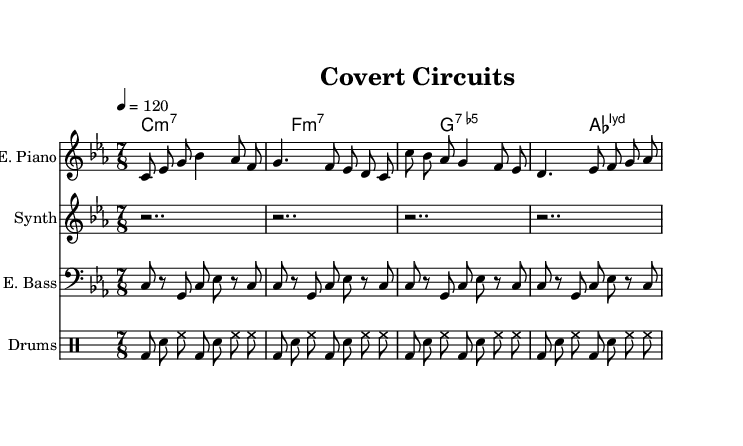What is the key signature of this music? The key signature is C minor, which is indicated by three flats (B♭, E♭, A♭) on the staff.
Answer: C minor What is the time signature of this music? The time signature is shown at the beginning of the music as 7/8, meaning there are seven beats in a bar, and the eighth note gets the beat.
Answer: 7/8 What is the tempo marking for this piece? The tempo marking is given as 4 = 120, indicating that there are 120 quarter notes per minute.
Answer: 120 How many measures are in the electric piano part? The electric piano part consists of four measures that can be counted visibly in the notation.
Answer: 4 What type of seventh chord is used in the chord progression? The chord progression includes a minor seventh chord, a minor seventh chord, and an altered dominant seventh chord indicated as G7.5-
Answer: Minor seventh Identify the rhythmic pattern of the drum kit The rhythmic pattern consists of a standard rock beat with bass drum and snare, emphasizing the first and third beats.
Answer: Standard rock beat 